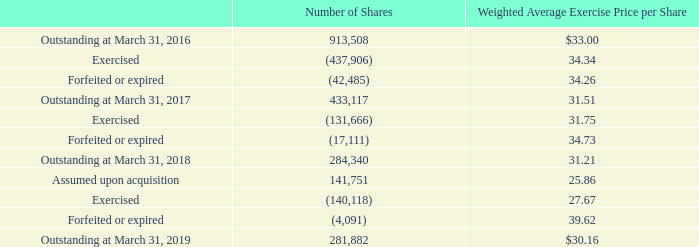Stock option and stock appreciation right (SAR) activity under the Company's stock incentive plans in the three years ended March 31, 2019 is set forth below:
The total intrinsic value of options and SARs exercised during the years ended March 31, 2019, 2018 and 2017 was $8.3 million, $7.4 million and $9.6 million, respectively. This intrinsic value represents the difference between the fair market value of the Company's common stock on the date of exercise and the exercise price of each equity award.
The aggregate intrinsic value of options and SARs outstanding at March 31, 2019 was $14.9 million. The aggregate intrinsic value of options and SARS exercisable at March 31, 2019 was $14.8 million. The aggregate intrinsic values were calculated based on the closing price of the Company's common stock of $82.96 per share on March 29, 2019.
As of March 31, 2019 and March 31, 2018, the number of option and SAR shares exercisable was 278,591 and 224,022, respectively, and the weighted average exercise price per share was $30.03 and $29.96, respectively.
There were no stock options granted in the years ended March 31, 2019, 2018 and 2017
What was the total intrinsic value of options and SARs exercised during the years ended March 31, 2019?
Answer scale should be: million. 8.3. What was the number of option and SAR shares exercisable in 2019? 278,591. Which years does the table provide the number of outstanding shares for? 2016, 2017, 2018, 2019. How many years did the outstanding number of shares exceed 500,000? 2016
Answer: 1. What was the change in the Weighted Average Exercise Price per Share for outstanding shares between 2017 and 2018? 31.21-31.51
Answer: -0.3. What was the percentage change in the number of outstanding shares between 2018 and 2019?
Answer scale should be: percent. (281,882-284,340)/284,340
Answer: -0.86. 